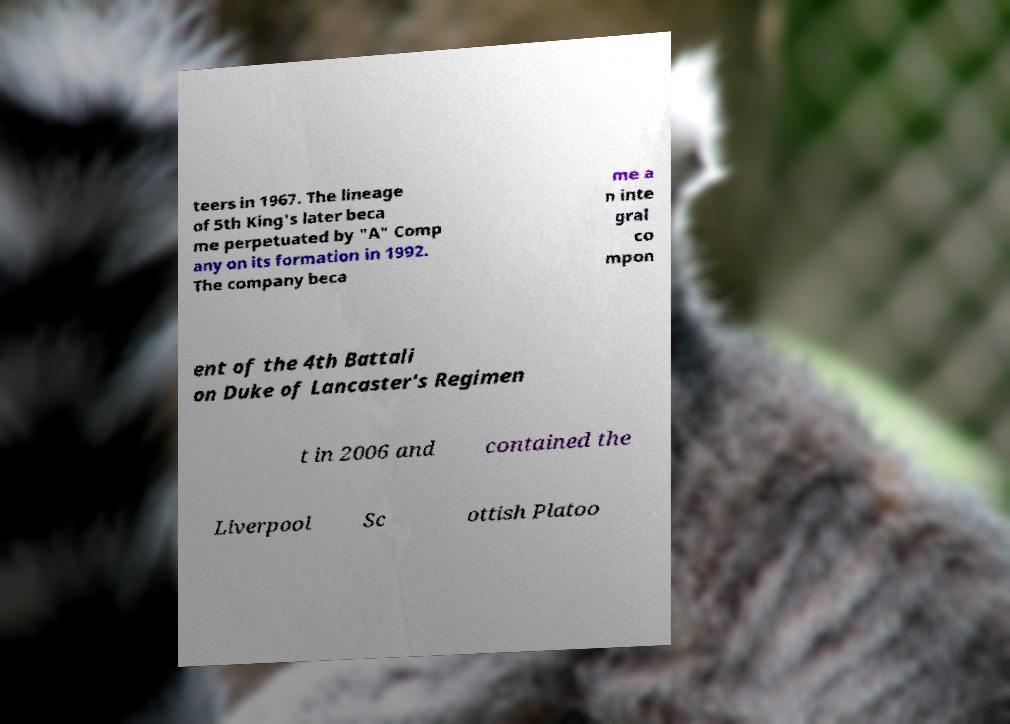Can you read and provide the text displayed in the image?This photo seems to have some interesting text. Can you extract and type it out for me? teers in 1967. The lineage of 5th King's later beca me perpetuated by "A" Comp any on its formation in 1992. The company beca me a n inte gral co mpon ent of the 4th Battali on Duke of Lancaster's Regimen t in 2006 and contained the Liverpool Sc ottish Platoo 